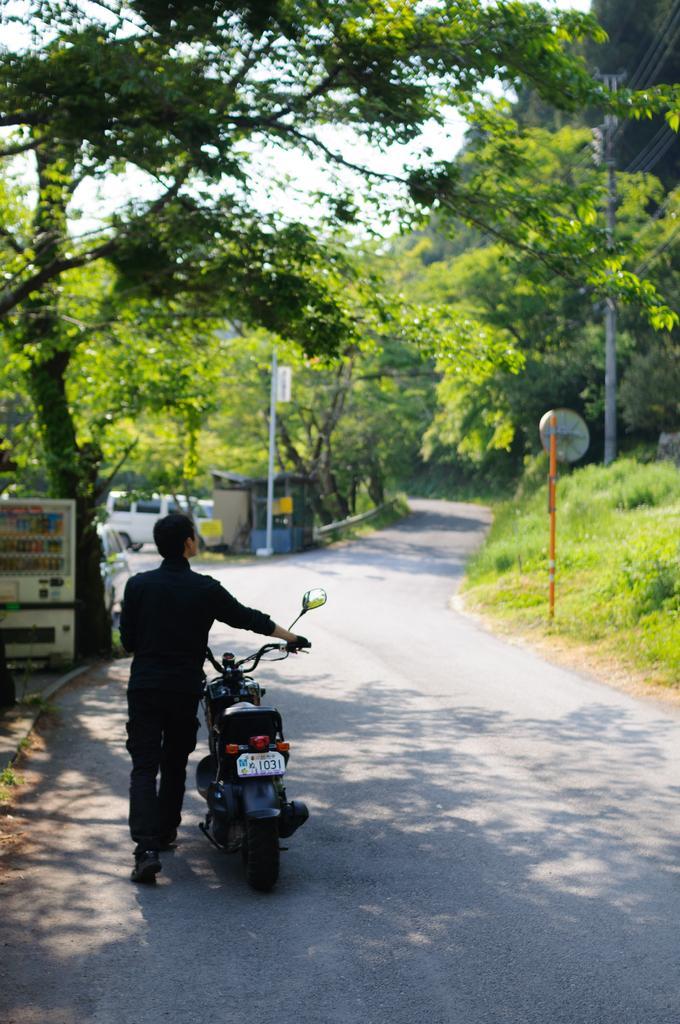Please provide a concise description of this image. There is a person walking and holding a bike. We can see grass, white object, trees, vehicle and building. In the background we can see sky. 